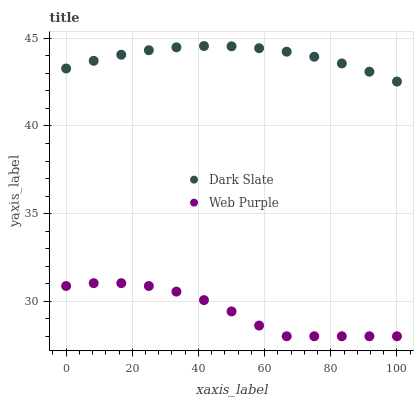Does Web Purple have the minimum area under the curve?
Answer yes or no. Yes. Does Dark Slate have the maximum area under the curve?
Answer yes or no. Yes. Does Web Purple have the maximum area under the curve?
Answer yes or no. No. Is Dark Slate the smoothest?
Answer yes or no. Yes. Is Web Purple the roughest?
Answer yes or no. Yes. Is Web Purple the smoothest?
Answer yes or no. No. Does Web Purple have the lowest value?
Answer yes or no. Yes. Does Dark Slate have the highest value?
Answer yes or no. Yes. Does Web Purple have the highest value?
Answer yes or no. No. Is Web Purple less than Dark Slate?
Answer yes or no. Yes. Is Dark Slate greater than Web Purple?
Answer yes or no. Yes. Does Web Purple intersect Dark Slate?
Answer yes or no. No. 